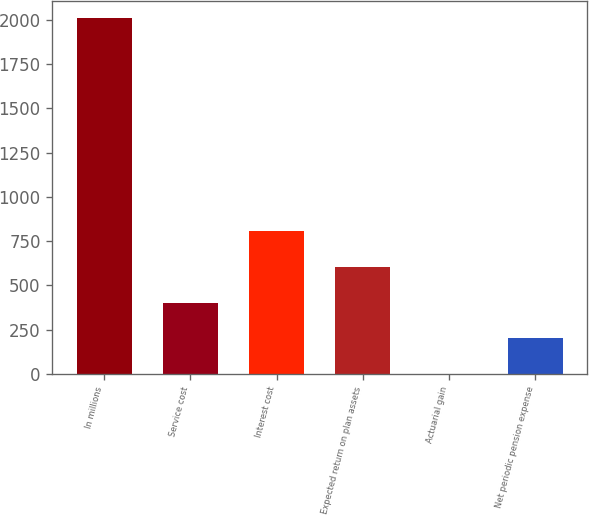<chart> <loc_0><loc_0><loc_500><loc_500><bar_chart><fcel>In millions<fcel>Service cost<fcel>Interest cost<fcel>Expected return on plan assets<fcel>Actuarial gain<fcel>Net periodic pension expense<nl><fcel>2009<fcel>403.4<fcel>804.8<fcel>604.1<fcel>2<fcel>202.7<nl></chart> 